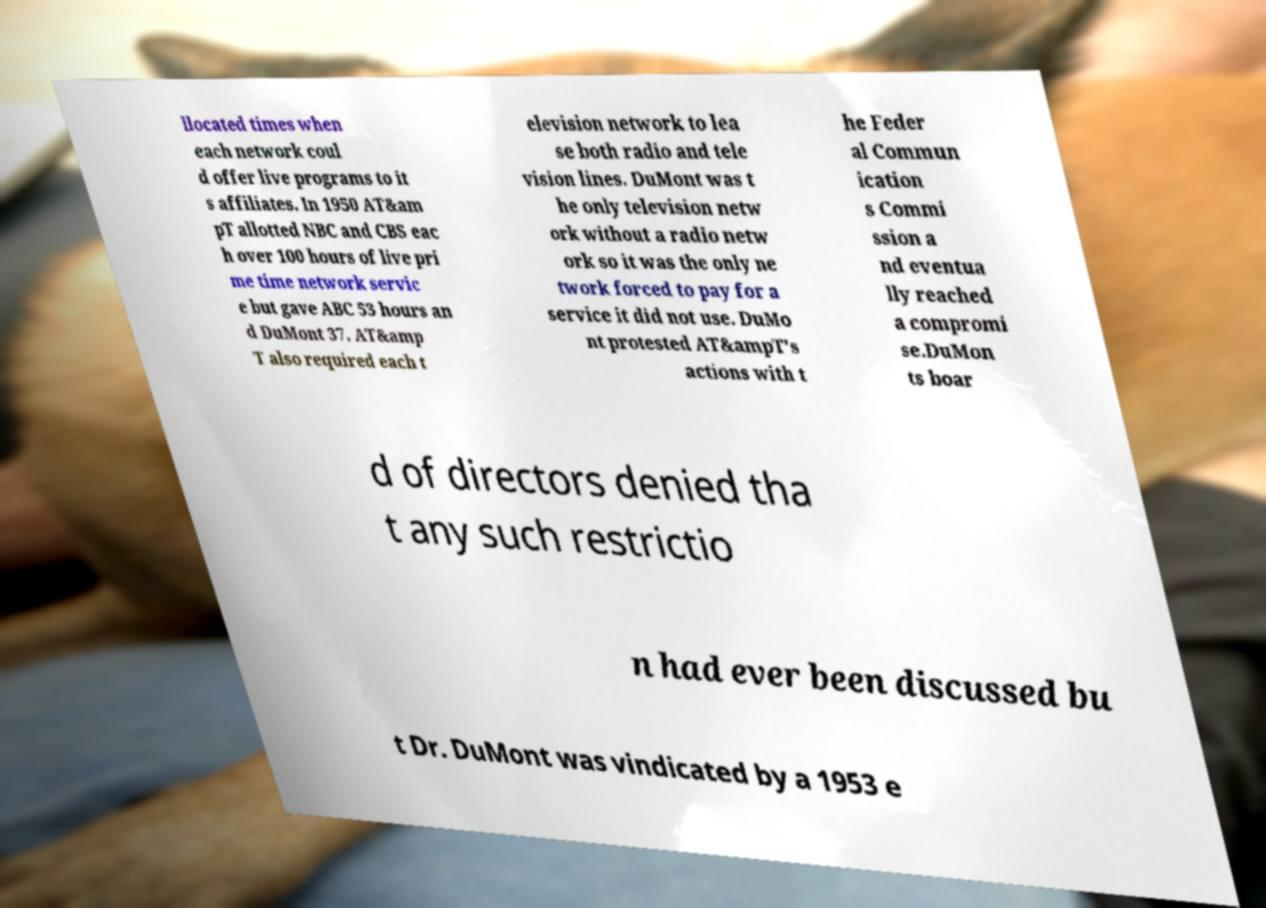Could you extract and type out the text from this image? llocated times when each network coul d offer live programs to it s affiliates. In 1950 AT&am pT allotted NBC and CBS eac h over 100 hours of live pri me time network servic e but gave ABC 53 hours an d DuMont 37. AT&amp T also required each t elevision network to lea se both radio and tele vision lines. DuMont was t he only television netw ork without a radio netw ork so it was the only ne twork forced to pay for a service it did not use. DuMo nt protested AT&ampT's actions with t he Feder al Commun ication s Commi ssion a nd eventua lly reached a compromi se.DuMon ts boar d of directors denied tha t any such restrictio n had ever been discussed bu t Dr. DuMont was vindicated by a 1953 e 